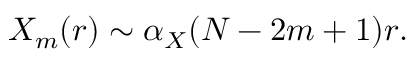<formula> <loc_0><loc_0><loc_500><loc_500>X _ { m } ( r ) \sim \alpha _ { X } ( N - 2 m + 1 ) r .</formula> 